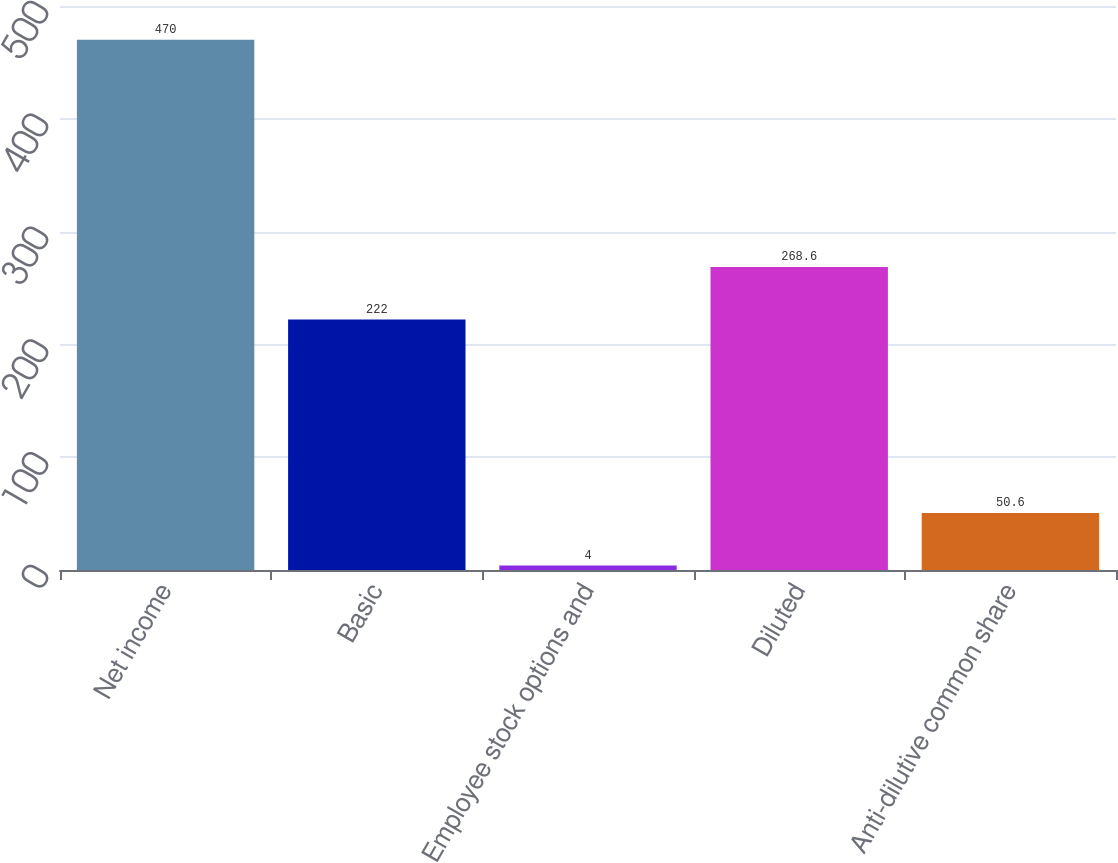Convert chart to OTSL. <chart><loc_0><loc_0><loc_500><loc_500><bar_chart><fcel>Net income<fcel>Basic<fcel>Employee stock options and<fcel>Diluted<fcel>Anti-dilutive common share<nl><fcel>470<fcel>222<fcel>4<fcel>268.6<fcel>50.6<nl></chart> 